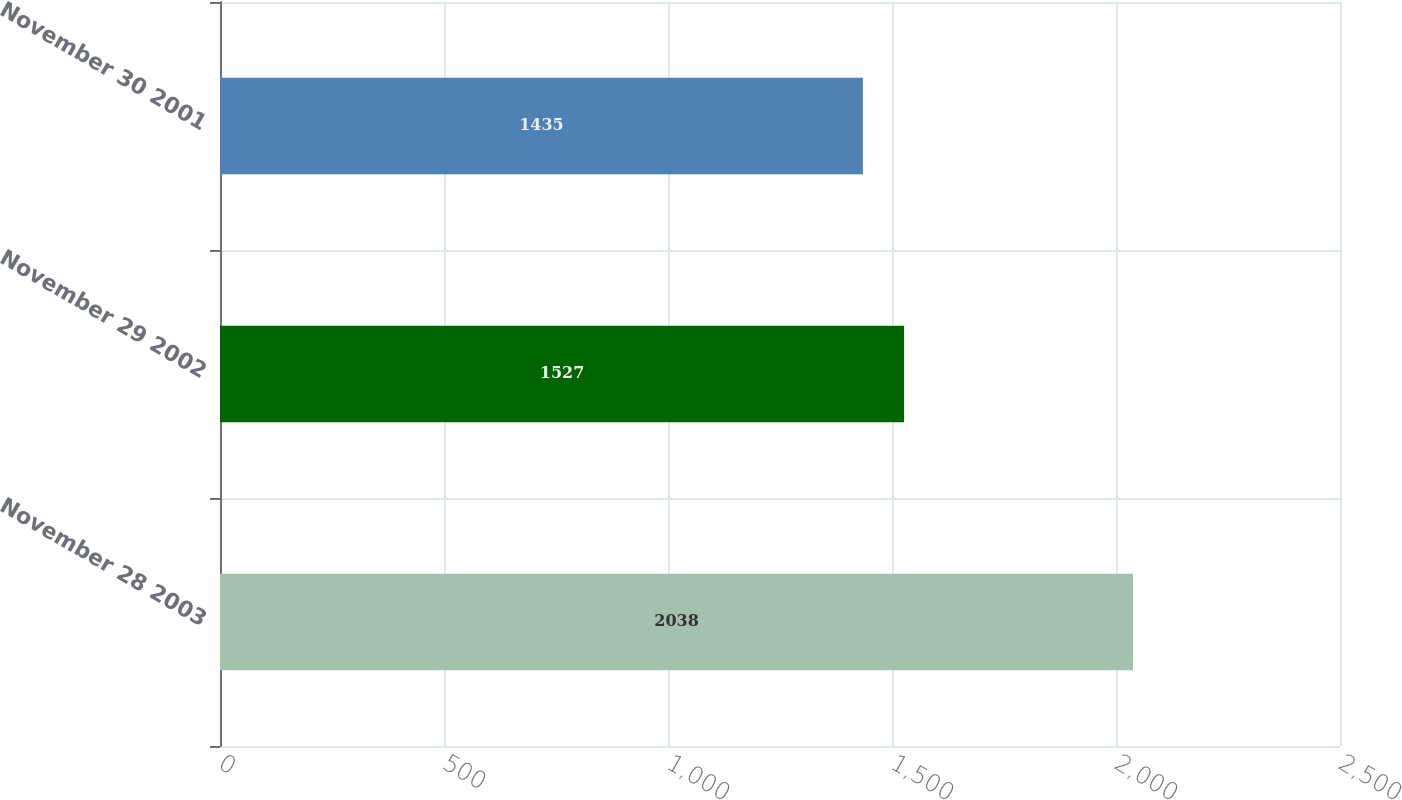Convert chart to OTSL. <chart><loc_0><loc_0><loc_500><loc_500><bar_chart><fcel>November 28 2003<fcel>November 29 2002<fcel>November 30 2001<nl><fcel>2038<fcel>1527<fcel>1435<nl></chart> 